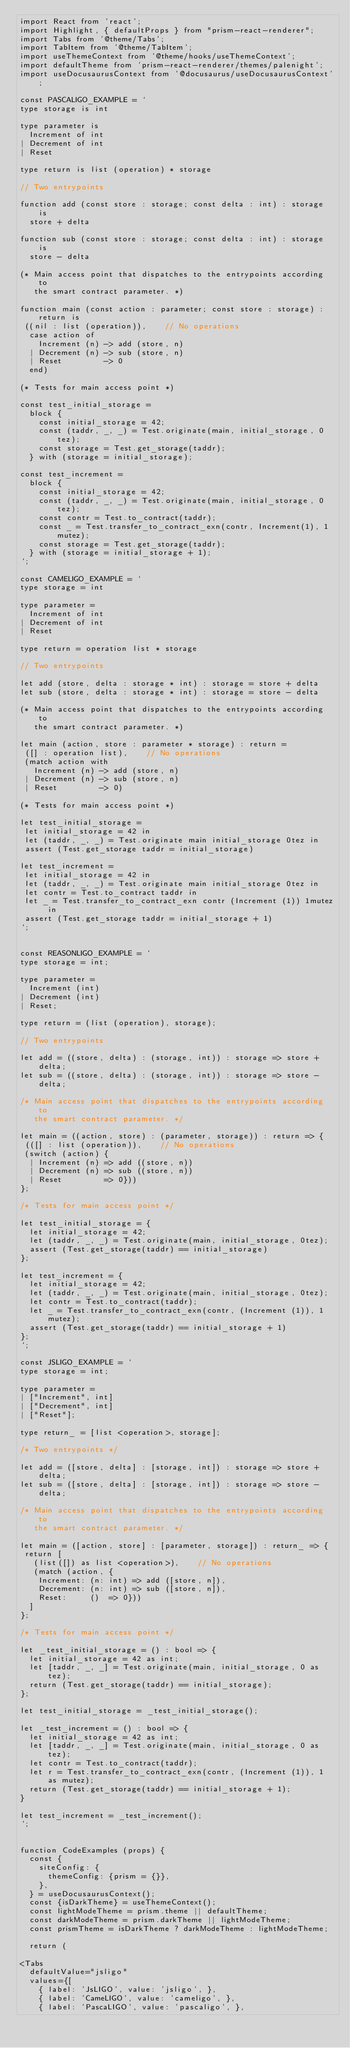Convert code to text. <code><loc_0><loc_0><loc_500><loc_500><_JavaScript_>import React from 'react';
import Highlight, { defaultProps } from "prism-react-renderer";
import Tabs from '@theme/Tabs';
import TabItem from '@theme/TabItem';
import useThemeContext from '@theme/hooks/useThemeContext';
import defaultTheme from 'prism-react-renderer/themes/palenight';
import useDocusaurusContext from '@docusaurus/useDocusaurusContext';

const PASCALIGO_EXAMPLE = `
type storage is int

type parameter is
  Increment of int
| Decrement of int
| Reset

type return is list (operation) * storage

// Two entrypoints

function add (const store : storage; const delta : int) : storage is 
  store + delta

function sub (const store : storage; const delta : int) : storage is 
  store - delta

(* Main access point that dispatches to the entrypoints according to
   the smart contract parameter. *)

function main (const action : parameter; const store : storage) : return is
 ((nil : list (operation)),    // No operations
  case action of
    Increment (n) -> add (store, n)
  | Decrement (n) -> sub (store, n)
  | Reset         -> 0
  end)

(* Tests for main access point *)

const test_initial_storage =
  block {
    const initial_storage = 42;
    const (taddr, _, _) = Test.originate(main, initial_storage, 0tez);
    const storage = Test.get_storage(taddr);
  } with (storage = initial_storage);

const test_increment =
  block {
    const initial_storage = 42;
    const (taddr, _, _) = Test.originate(main, initial_storage, 0tez);
    const contr = Test.to_contract(taddr);
    const _ = Test.transfer_to_contract_exn(contr, Increment(1), 1mutez);
    const storage = Test.get_storage(taddr);
  } with (storage = initial_storage + 1);
`;

const CAMELIGO_EXAMPLE = `
type storage = int

type parameter =
  Increment of int
| Decrement of int
| Reset

type return = operation list * storage

// Two entrypoints

let add (store, delta : storage * int) : storage = store + delta
let sub (store, delta : storage * int) : storage = store - delta

(* Main access point that dispatches to the entrypoints according to
   the smart contract parameter. *)

let main (action, store : parameter * storage) : return =
 ([] : operation list),    // No operations
 (match action with
   Increment (n) -> add (store, n)
 | Decrement (n) -> sub (store, n)
 | Reset         -> 0)

(* Tests for main access point *)

let test_initial_storage =
 let initial_storage = 42 in
 let (taddr, _, _) = Test.originate main initial_storage 0tez in
 assert (Test.get_storage taddr = initial_storage)

let test_increment =
 let initial_storage = 42 in
 let (taddr, _, _) = Test.originate main initial_storage 0tez in
 let contr = Test.to_contract taddr in
 let _ = Test.transfer_to_contract_exn contr (Increment (1)) 1mutez in
 assert (Test.get_storage taddr = initial_storage + 1)
`;


const REASONLIGO_EXAMPLE = `
type storage = int;

type parameter =
  Increment (int)
| Decrement (int)
| Reset;

type return = (list (operation), storage);

// Two entrypoints

let add = ((store, delta) : (storage, int)) : storage => store + delta;
let sub = ((store, delta) : (storage, int)) : storage => store - delta;

/* Main access point that dispatches to the entrypoints according to
   the smart contract parameter. */

let main = ((action, store) : (parameter, storage)) : return => {
 (([] : list (operation)),    // No operations
 (switch (action) {
  | Increment (n) => add ((store, n))
  | Decrement (n) => sub ((store, n))
  | Reset         => 0}))
};

/* Tests for main access point */

let test_initial_storage = {
  let initial_storage = 42;
  let (taddr, _, _) = Test.originate(main, initial_storage, 0tez);
  assert (Test.get_storage(taddr) == initial_storage)
};

let test_increment = {
  let initial_storage = 42;
  let (taddr, _, _) = Test.originate(main, initial_storage, 0tez);
  let contr = Test.to_contract(taddr);
  let _ = Test.transfer_to_contract_exn(contr, (Increment (1)), 1mutez);
  assert (Test.get_storage(taddr) == initial_storage + 1)
};
`;

const JSLIGO_EXAMPLE = `
type storage = int;

type parameter =
| ["Increment", int]
| ["Decrement", int]
| ["Reset"];

type return_ = [list <operation>, storage];

/* Two entrypoints */

let add = ([store, delta] : [storage, int]) : storage => store + delta;
let sub = ([store, delta] : [storage, int]) : storage => store - delta;

/* Main access point that dispatches to the entrypoints according to
   the smart contract parameter. */

let main = ([action, store] : [parameter, storage]) : return_ => {
 return [
   (list([]) as list <operation>),    // No operations
   (match (action, {
    Increment: (n: int) => add ([store, n]),
    Decrement: (n: int) => sub ([store, n]),
    Reset:     ()  => 0}))
  ]
};

/* Tests for main access point */

let _test_initial_storage = () : bool => {
  let initial_storage = 42 as int;
  let [taddr, _, _] = Test.originate(main, initial_storage, 0 as tez);
  return (Test.get_storage(taddr) == initial_storage);
};

let test_initial_storage = _test_initial_storage();

let _test_increment = () : bool => {
  let initial_storage = 42 as int;
  let [taddr, _, _] = Test.originate(main, initial_storage, 0 as tez);
  let contr = Test.to_contract(taddr);
  let r = Test.transfer_to_contract_exn(contr, (Increment (1)), 1 as mutez);
  return (Test.get_storage(taddr) == initial_storage + 1);
}

let test_increment = _test_increment();
`;


function CodeExamples (props) {
  const {
    siteConfig: {
      themeConfig: {prism = {}},
    },
  } = useDocusaurusContext();
  const {isDarkTheme} = useThemeContext();
  const lightModeTheme = prism.theme || defaultTheme;
  const darkModeTheme = prism.darkTheme || lightModeTheme;
  const prismTheme = isDarkTheme ? darkModeTheme : lightModeTheme;

  return (
   
<Tabs
  defaultValue="jsligo"
  values={[
    { label: 'JsLIGO', value: 'jsligo', },
    { label: 'CameLIGO', value: 'cameligo', },
    { label: 'PascaLIGO', value: 'pascaligo', },</code> 